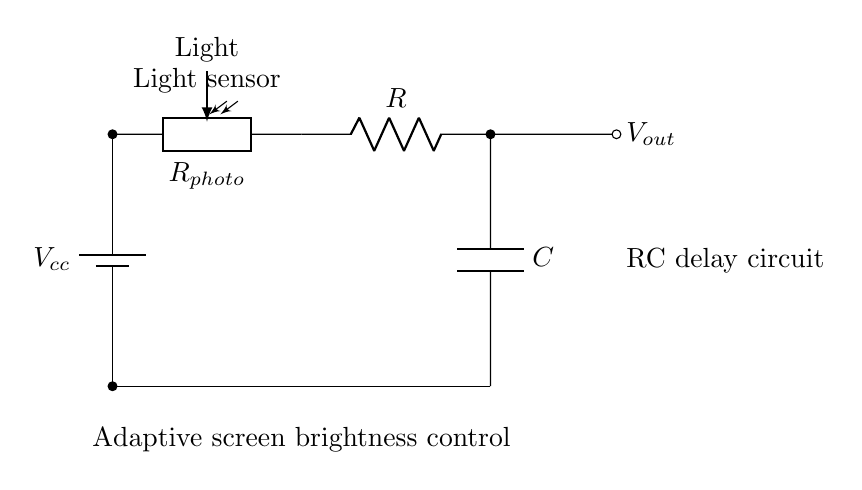What is the power supply voltage in this circuit? The power supply voltage is indicated as Vcc, which is the voltage source connected at the top of the circuit.
Answer: Vcc What component is used as a light sensor in the circuit? The component used for light sensing is labeled as Rphoto, which is a photoresistor.
Answer: Photoresistor What is the role of the capacitor in this circuit? The capacitor, labeled C, helps to smooth out fluctuations in the output voltage, providing a delay effect by charging and discharging over time.
Answer: Delay effect How many components are connected in series in this circuit? The circuit has three main components connected in series: the photoresistor, the resistor, and the capacitor, which form a single pathway from the power supply to ground.
Answer: Three What happens to the output voltage when the light intensity increases? When light intensity increases, the resistance of the photoresistor decreases, leading to a higher voltage at the output node Vout.
Answer: Increases What type of circuit is shown here? The circuit is identified as an RC delay circuit, which utilizes both a resistor and a capacitor to implement time delay functionality for adaptive control.
Answer: RC delay circuit 